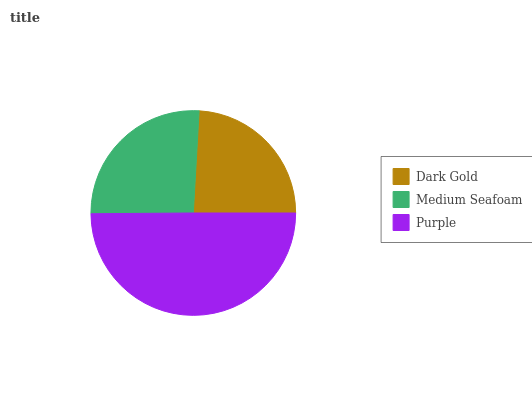Is Dark Gold the minimum?
Answer yes or no. Yes. Is Purple the maximum?
Answer yes or no. Yes. Is Medium Seafoam the minimum?
Answer yes or no. No. Is Medium Seafoam the maximum?
Answer yes or no. No. Is Medium Seafoam greater than Dark Gold?
Answer yes or no. Yes. Is Dark Gold less than Medium Seafoam?
Answer yes or no. Yes. Is Dark Gold greater than Medium Seafoam?
Answer yes or no. No. Is Medium Seafoam less than Dark Gold?
Answer yes or no. No. Is Medium Seafoam the high median?
Answer yes or no. Yes. Is Medium Seafoam the low median?
Answer yes or no. Yes. Is Dark Gold the high median?
Answer yes or no. No. Is Purple the low median?
Answer yes or no. No. 